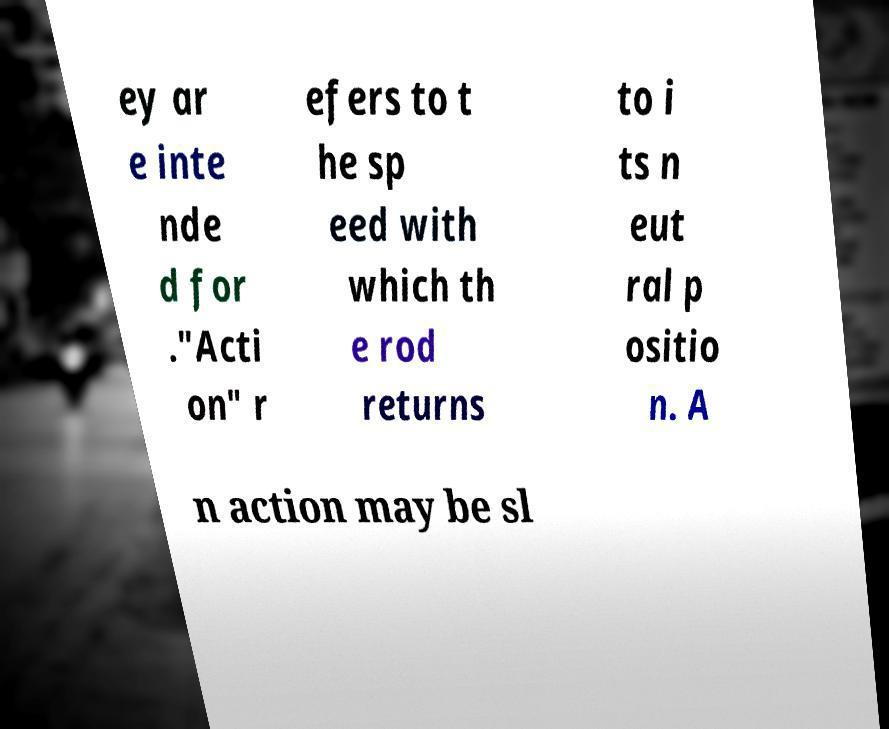I need the written content from this picture converted into text. Can you do that? ey ar e inte nde d for ."Acti on" r efers to t he sp eed with which th e rod returns to i ts n eut ral p ositio n. A n action may be sl 